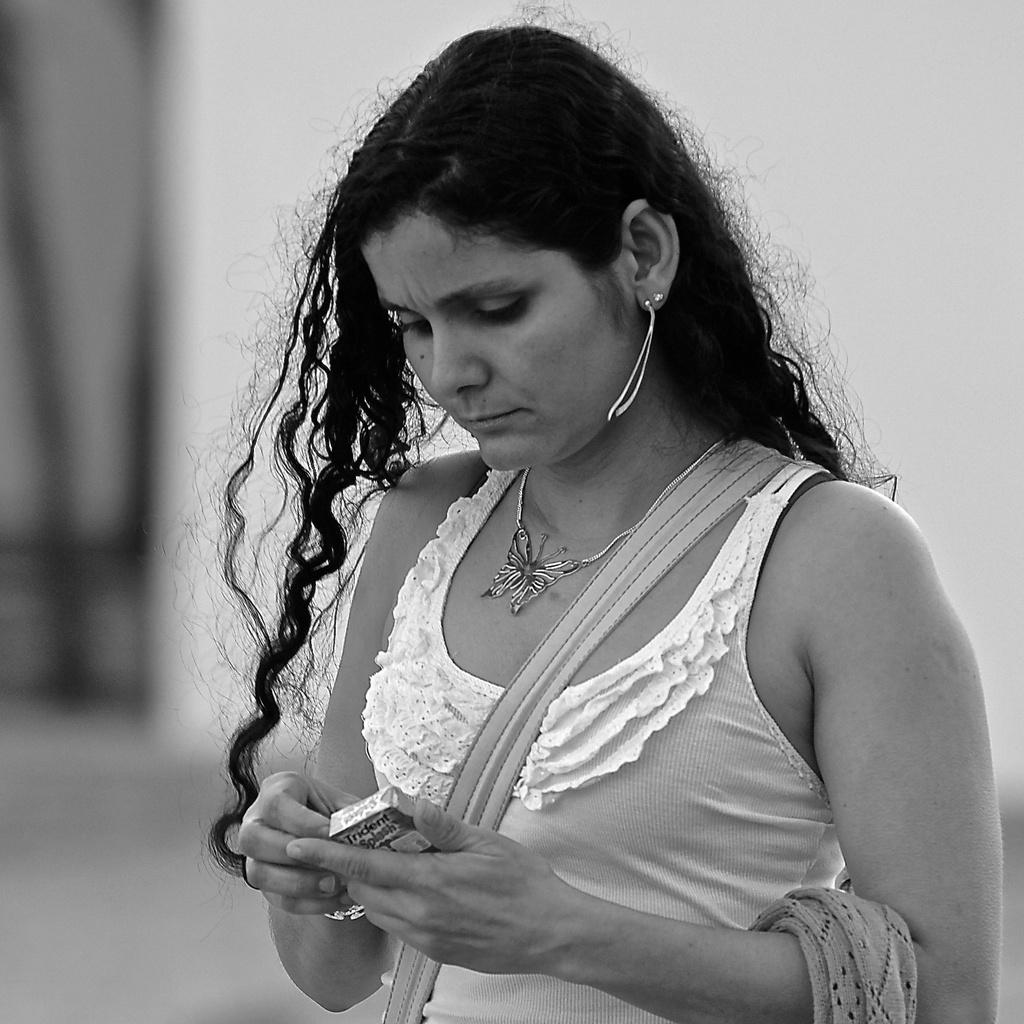Who is present in the image? There is a woman in the image. What is the woman doing in the image? The woman is holding an object and looking at it. Can you describe the background of the image? The background of the image is blurred. What type of monkey is sitting on the woman's shoulder in the image? There is no monkey present in the image; it only features a woman holding an object and looking at it. 